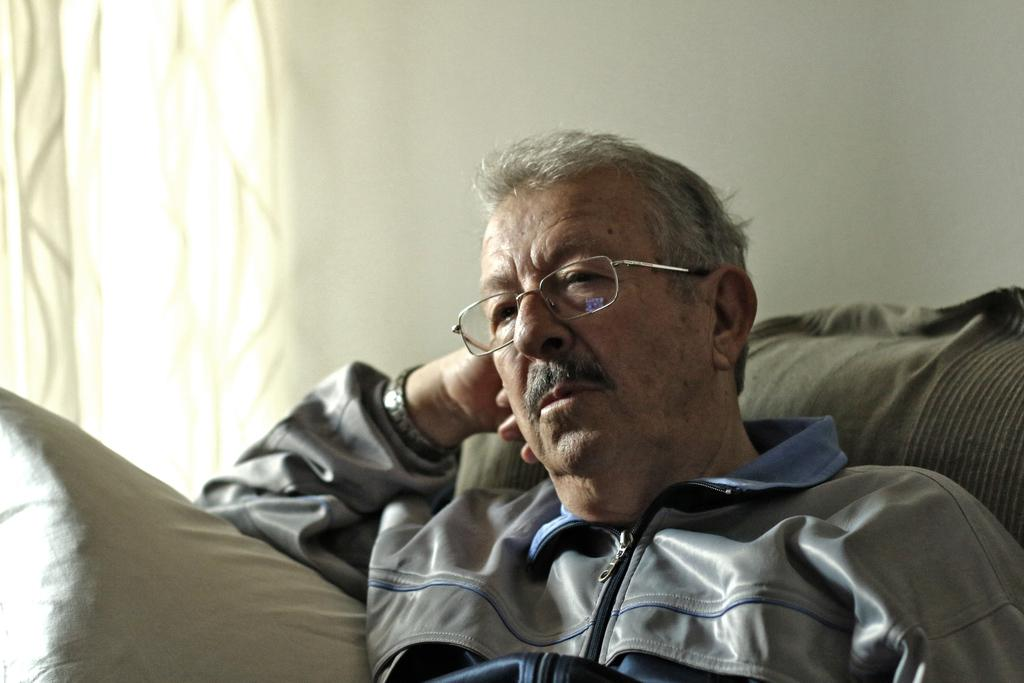Who is present in the image? There is a man in the image. What is the man wearing? The man is wearing a jacket. What is the man doing in the image? The man is sitting on a couch. What can be seen in the background of the image? There is a wall in the background of the image. What type of quilt is the man using to laugh in the image? There is no quilt or laughter present in the image; the man is simply sitting on a couch wearing a jacket. 